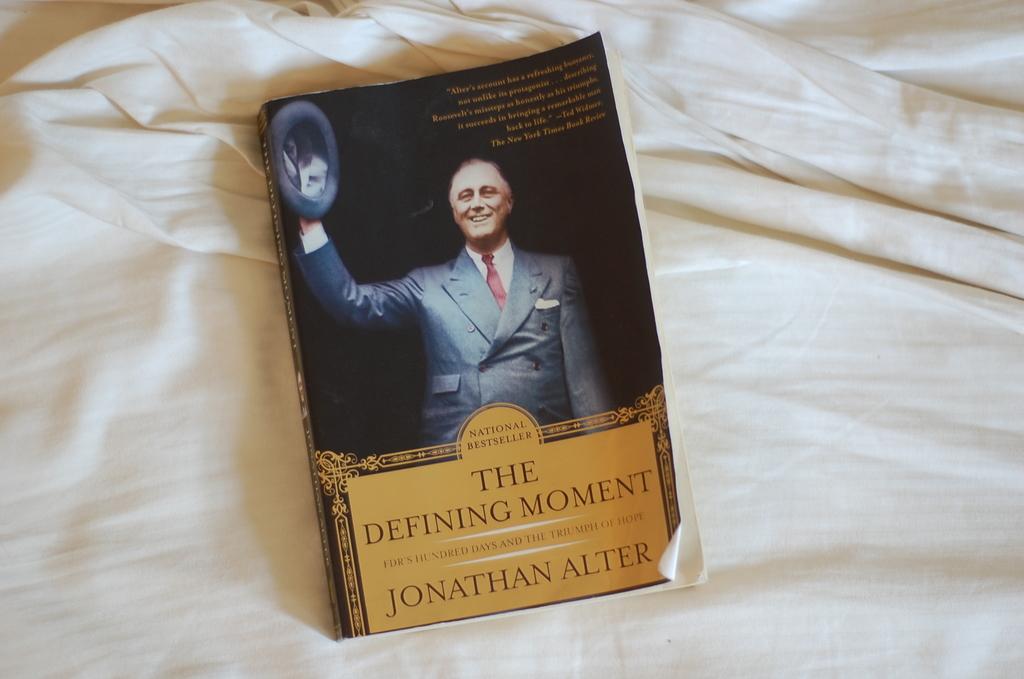What is this book called?
Ensure brevity in your answer.  The defining moment. 